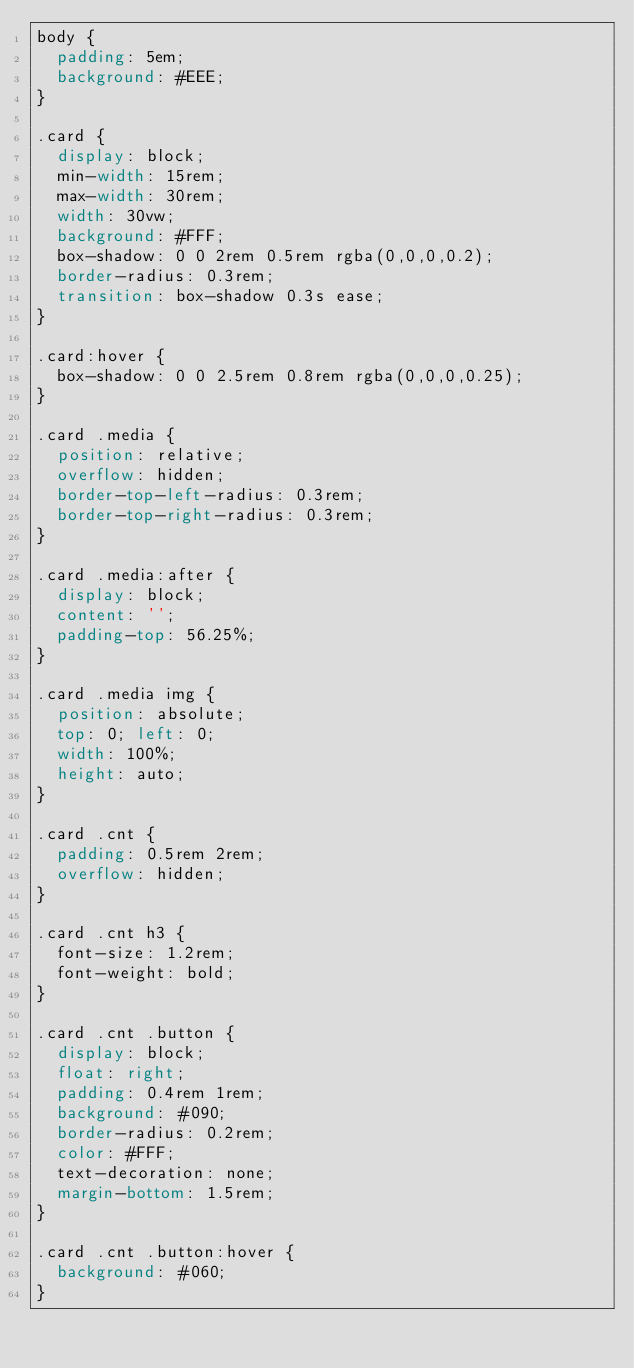Convert code to text. <code><loc_0><loc_0><loc_500><loc_500><_CSS_>body {
	padding: 5em;
	background: #EEE;
}

.card {
	display: block;
	min-width: 15rem;
	max-width: 30rem;
	width: 30vw;
	background: #FFF;
	box-shadow: 0 0 2rem 0.5rem rgba(0,0,0,0.2);
	border-radius: 0.3rem;
	transition: box-shadow 0.3s ease;
}

.card:hover {
	box-shadow: 0 0 2.5rem 0.8rem rgba(0,0,0,0.25);
}

.card .media {
	position: relative;
	overflow: hidden;
	border-top-left-radius: 0.3rem;
	border-top-right-radius: 0.3rem;
}

.card .media:after {
	display: block;
	content: '';
	padding-top: 56.25%;
}

.card .media img {
	position: absolute;
	top: 0; left: 0;
	width: 100%;
	height: auto;
}

.card .cnt {
	padding: 0.5rem 2rem;
	overflow: hidden;
}

.card .cnt h3 {
	font-size: 1.2rem;
	font-weight: bold;
}

.card .cnt .button {
	display: block;
	float: right;
	padding: 0.4rem 1rem;
	background: #090;
	border-radius: 0.2rem;
	color: #FFF;
	text-decoration: none;
	margin-bottom: 1.5rem;
}

.card .cnt .button:hover {
	background: #060;
}
</code> 